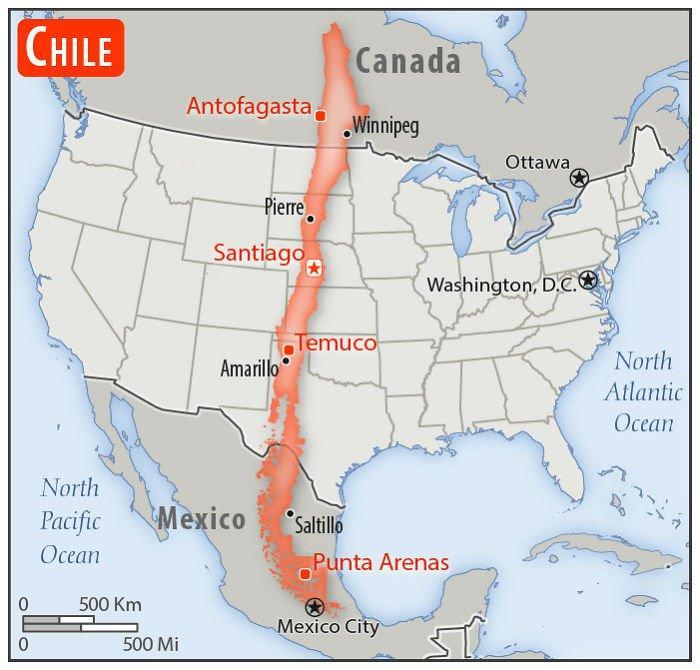Which country's name is written within the red rectangle?
Answer the question with a short phrase. Chile Which place is marked to the North of Washington, D.C.? Ottawa How many countries are shown in the map ? 4 How many oceans are shown in the map ? 2 Which place is marked to east of Santiago? Washington, D.C. 